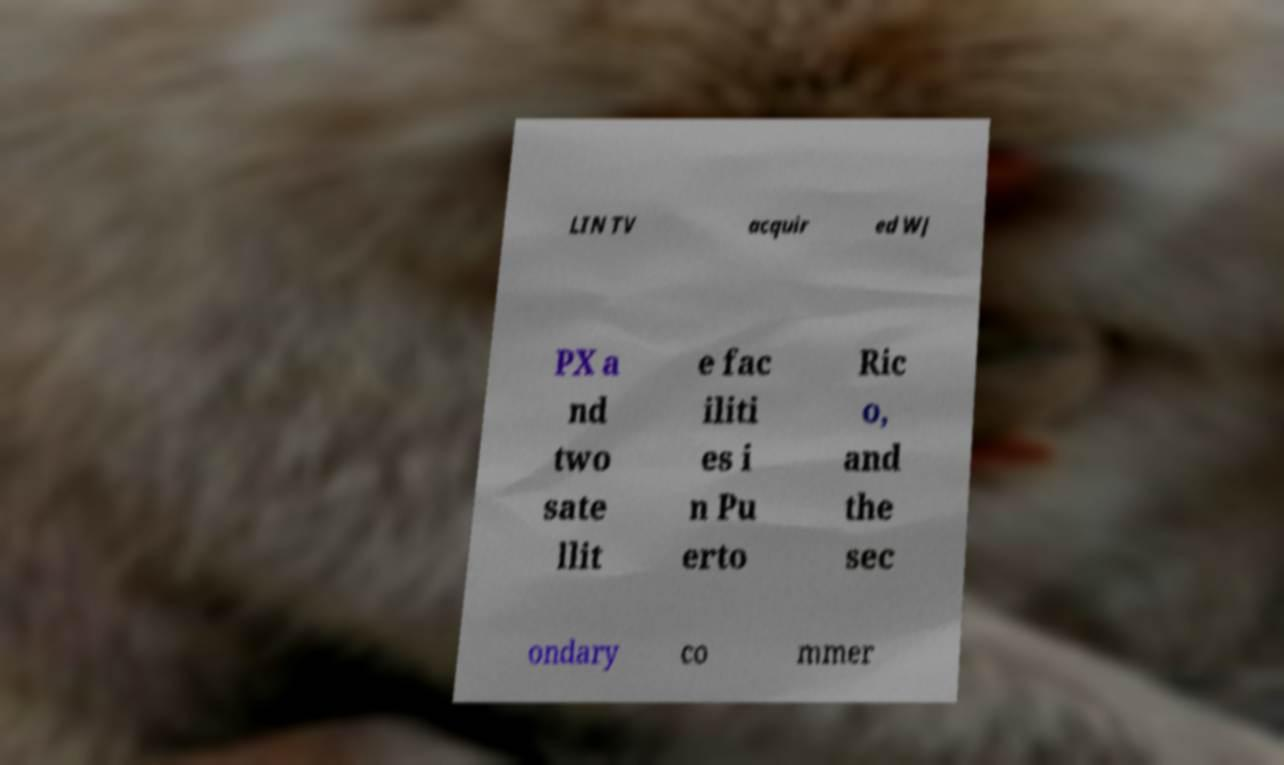Can you read and provide the text displayed in the image?This photo seems to have some interesting text. Can you extract and type it out for me? LIN TV acquir ed WJ PX a nd two sate llit e fac iliti es i n Pu erto Ric o, and the sec ondary co mmer 